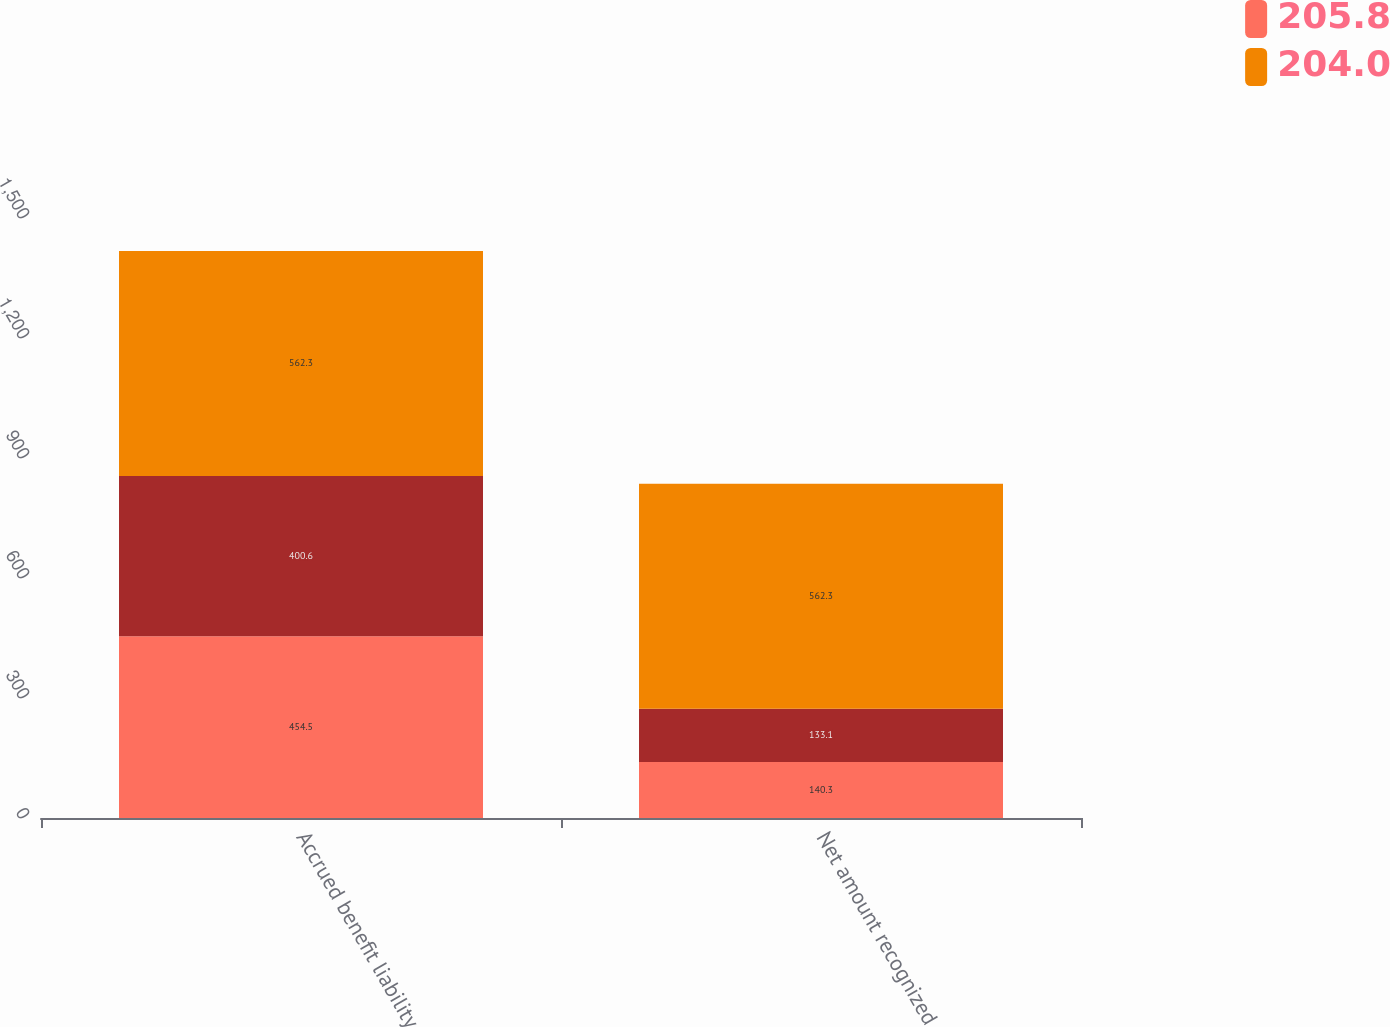<chart> <loc_0><loc_0><loc_500><loc_500><stacked_bar_chart><ecel><fcel>Accrued benefit liability<fcel>Net amount recognized<nl><fcel>205.8<fcel>454.5<fcel>140.3<nl><fcel>nan<fcel>400.6<fcel>133.1<nl><fcel>204<fcel>562.3<fcel>562.3<nl></chart> 